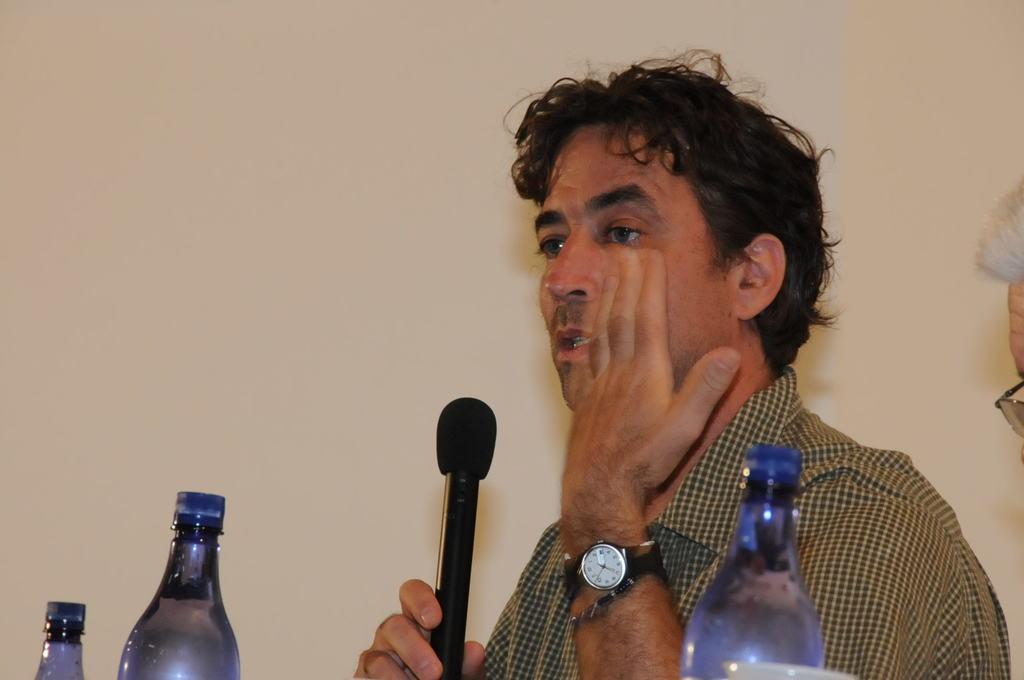In one or two sentences, can you explain what this image depicts? In this image a person wearing a watch is holding a mike. There are three bottles before this person. At the right side there is a person. 